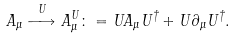Convert formula to latex. <formula><loc_0><loc_0><loc_500><loc_500>A _ { \mu } \stackrel { U } { \longrightarrow } A _ { \mu } ^ { U } \colon = U A _ { \mu } U ^ { \dagger } + U \partial _ { \mu } U ^ { \dagger } .</formula> 